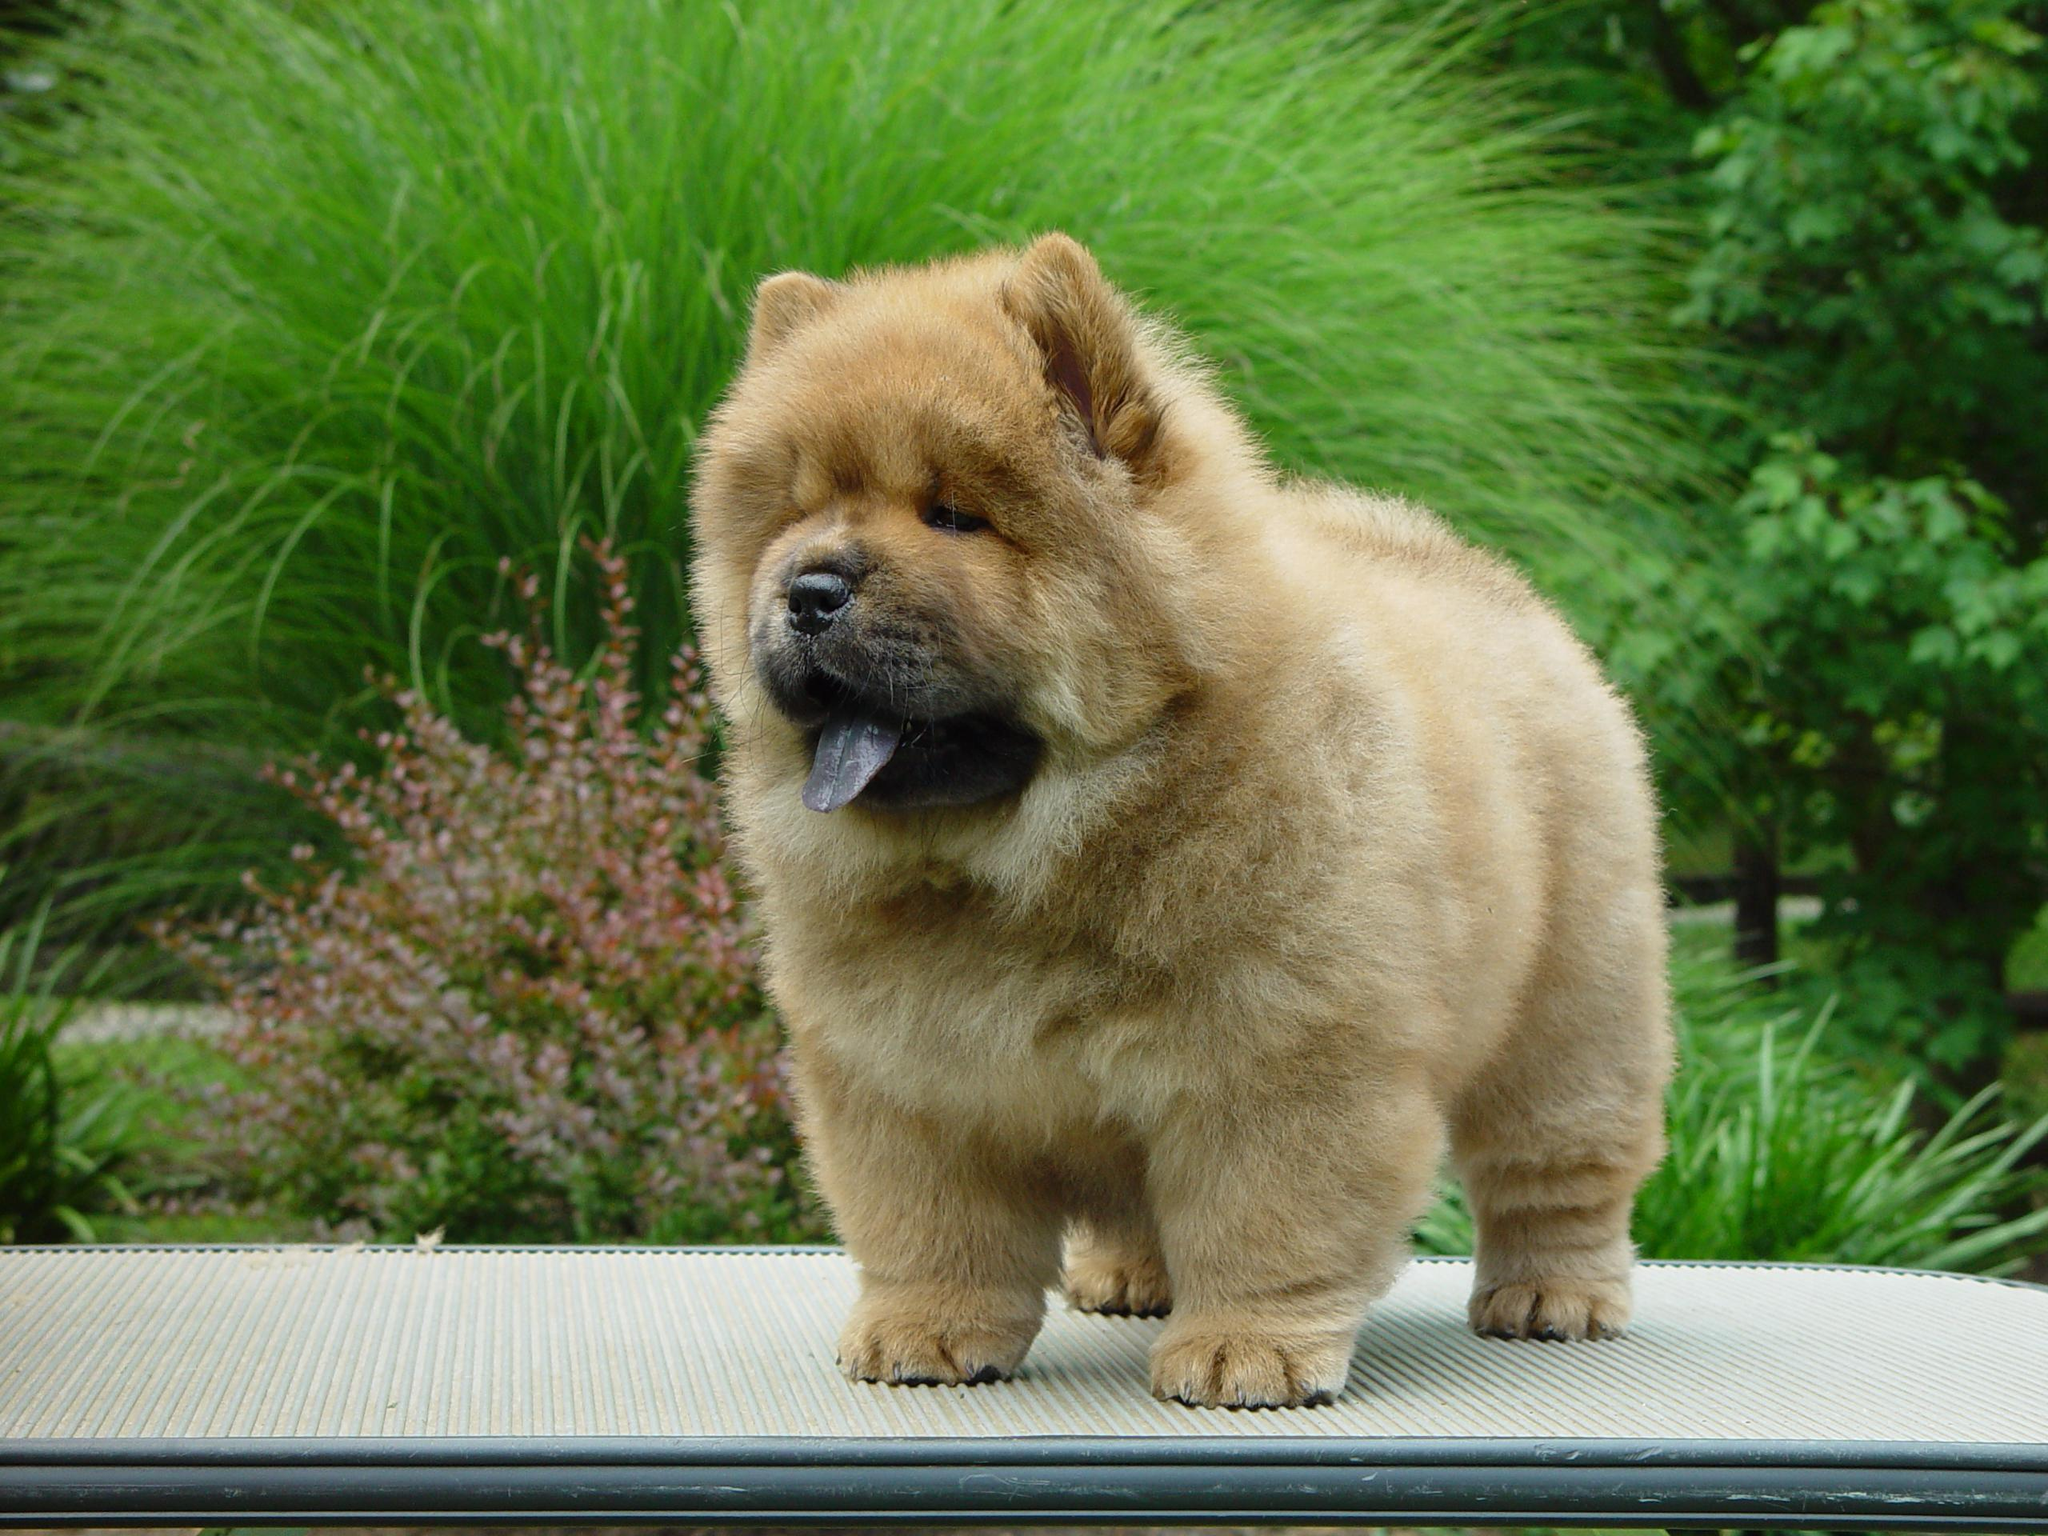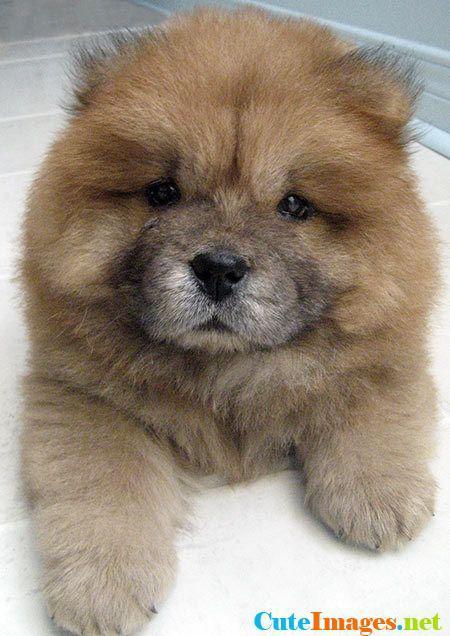The first image is the image on the left, the second image is the image on the right. Assess this claim about the two images: "The dog in the image on the left is lying down.". Correct or not? Answer yes or no. No. The first image is the image on the left, the second image is the image on the right. Given the left and right images, does the statement "One image shows a chow dog posed in front of something with green foliage, and each image contains a single dog." hold true? Answer yes or no. Yes. 